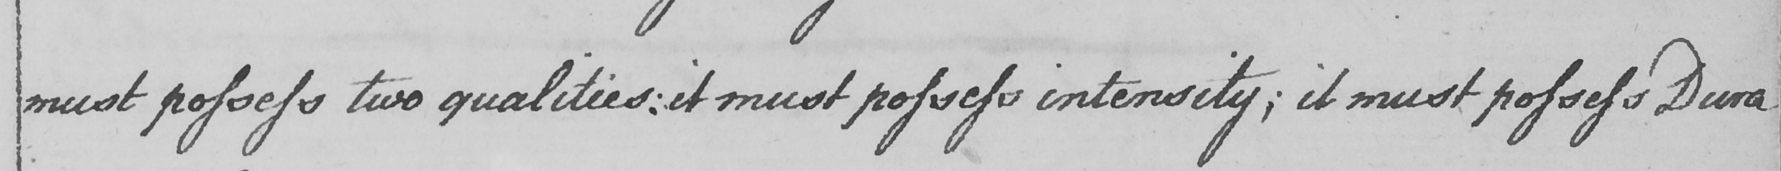Transcribe the text shown in this historical manuscript line. must possess two qualities :  it must possess intensity ; it must possess Dura 